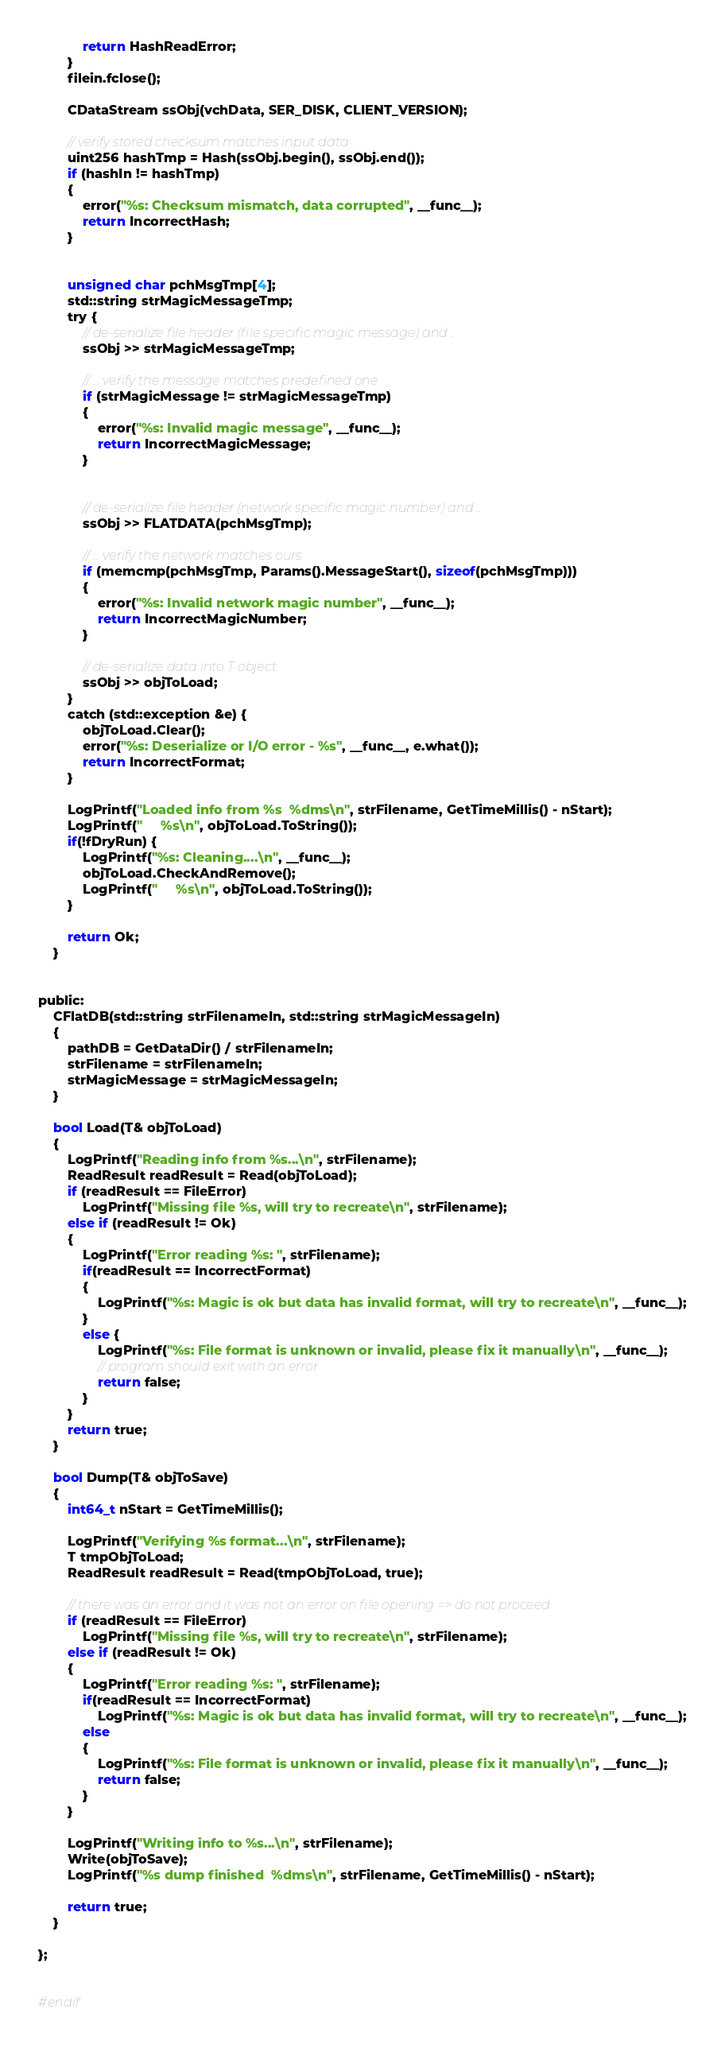<code> <loc_0><loc_0><loc_500><loc_500><_C_>            return HashReadError;
        }
        filein.fclose();

        CDataStream ssObj(vchData, SER_DISK, CLIENT_VERSION);

        // verify stored checksum matches input data
        uint256 hashTmp = Hash(ssObj.begin(), ssObj.end());
        if (hashIn != hashTmp)
        {
            error("%s: Checksum mismatch, data corrupted", __func__);
            return IncorrectHash;
        }


        unsigned char pchMsgTmp[4];
        std::string strMagicMessageTmp;
        try {
            // de-serialize file header (file specific magic message) and ..
            ssObj >> strMagicMessageTmp;

            // ... verify the message matches predefined one
            if (strMagicMessage != strMagicMessageTmp)
            {
                error("%s: Invalid magic message", __func__);
                return IncorrectMagicMessage;
            }


            // de-serialize file header (network specific magic number) and ..
            ssObj >> FLATDATA(pchMsgTmp);

            // ... verify the network matches ours
            if (memcmp(pchMsgTmp, Params().MessageStart(), sizeof(pchMsgTmp)))
            {
                error("%s: Invalid network magic number", __func__);
                return IncorrectMagicNumber;
            }

            // de-serialize data into T object
            ssObj >> objToLoad;
        }
        catch (std::exception &e) {
            objToLoad.Clear();
            error("%s: Deserialize or I/O error - %s", __func__, e.what());
            return IncorrectFormat;
        }

        LogPrintf("Loaded info from %s  %dms\n", strFilename, GetTimeMillis() - nStart);
        LogPrintf("     %s\n", objToLoad.ToString());
        if(!fDryRun) {
            LogPrintf("%s: Cleaning....\n", __func__);
            objToLoad.CheckAndRemove();
            LogPrintf("     %s\n", objToLoad.ToString());
        }

        return Ok;
    }


public:
    CFlatDB(std::string strFilenameIn, std::string strMagicMessageIn)
    {
        pathDB = GetDataDir() / strFilenameIn;
        strFilename = strFilenameIn;
        strMagicMessage = strMagicMessageIn;
    }

    bool Load(T& objToLoad)
    {
        LogPrintf("Reading info from %s...\n", strFilename);
        ReadResult readResult = Read(objToLoad);
        if (readResult == FileError)
            LogPrintf("Missing file %s, will try to recreate\n", strFilename);
        else if (readResult != Ok)
        {
            LogPrintf("Error reading %s: ", strFilename);
            if(readResult == IncorrectFormat)
            {
                LogPrintf("%s: Magic is ok but data has invalid format, will try to recreate\n", __func__);
            }
            else {
                LogPrintf("%s: File format is unknown or invalid, please fix it manually\n", __func__);
                // program should exit with an error
                return false;
            }
        }
        return true;
    }

    bool Dump(T& objToSave)
    {
        int64_t nStart = GetTimeMillis();

        LogPrintf("Verifying %s format...\n", strFilename);
        T tmpObjToLoad;
        ReadResult readResult = Read(tmpObjToLoad, true);

        // there was an error and it was not an error on file opening => do not proceed
        if (readResult == FileError)
            LogPrintf("Missing file %s, will try to recreate\n", strFilename);
        else if (readResult != Ok)
        {
            LogPrintf("Error reading %s: ", strFilename);
            if(readResult == IncorrectFormat)
                LogPrintf("%s: Magic is ok but data has invalid format, will try to recreate\n", __func__);
            else
            {
                LogPrintf("%s: File format is unknown or invalid, please fix it manually\n", __func__);
                return false;
            }
        }

        LogPrintf("Writing info to %s...\n", strFilename);
        Write(objToSave);
        LogPrintf("%s dump finished  %dms\n", strFilename, GetTimeMillis() - nStart);

        return true;
    }

};


#endif
</code> 